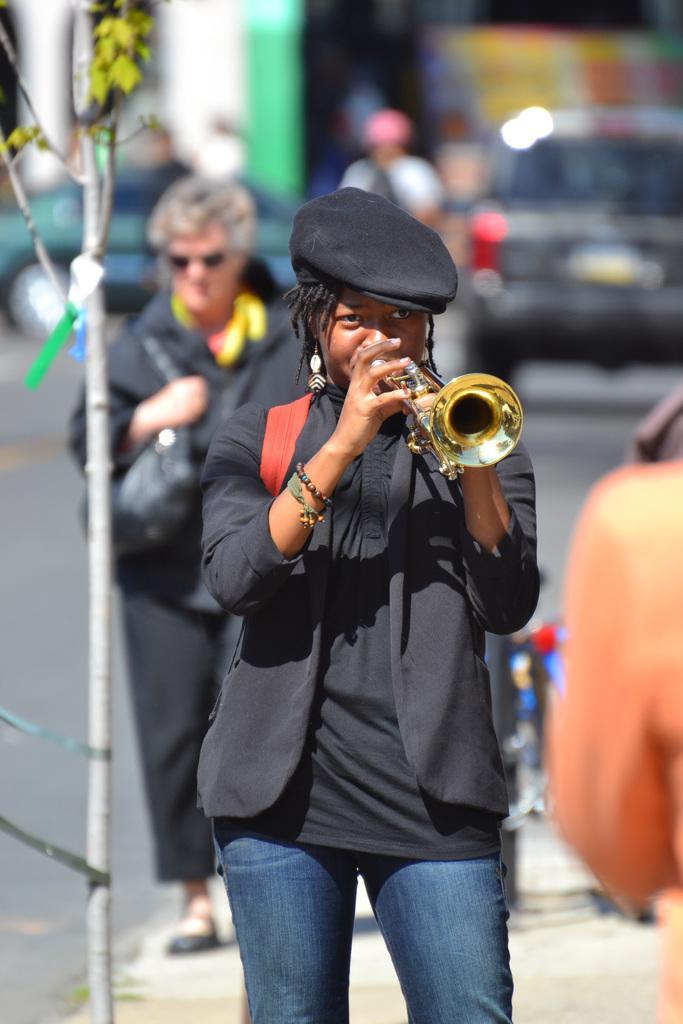How would you summarize this image in a sentence or two? In this image, we can see a woman is playing a musical instrument. and wearing a cap. Background there is a blur view. Here we can see few people and vehicles on the road. At the bottom, we can see a walkway. 